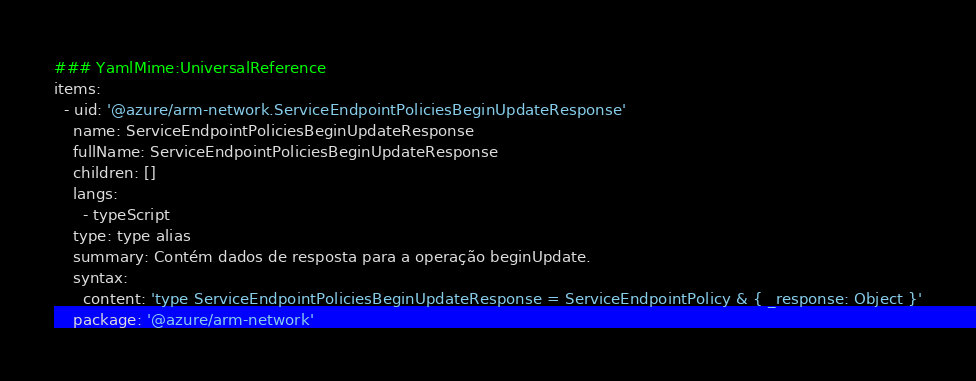Convert code to text. <code><loc_0><loc_0><loc_500><loc_500><_YAML_>### YamlMime:UniversalReference
items:
  - uid: '@azure/arm-network.ServiceEndpointPoliciesBeginUpdateResponse'
    name: ServiceEndpointPoliciesBeginUpdateResponse
    fullName: ServiceEndpointPoliciesBeginUpdateResponse
    children: []
    langs:
      - typeScript
    type: type alias
    summary: Contém dados de resposta para a operação beginUpdate.
    syntax:
      content: 'type ServiceEndpointPoliciesBeginUpdateResponse = ServiceEndpointPolicy & { _response: Object }'
    package: '@azure/arm-network'</code> 